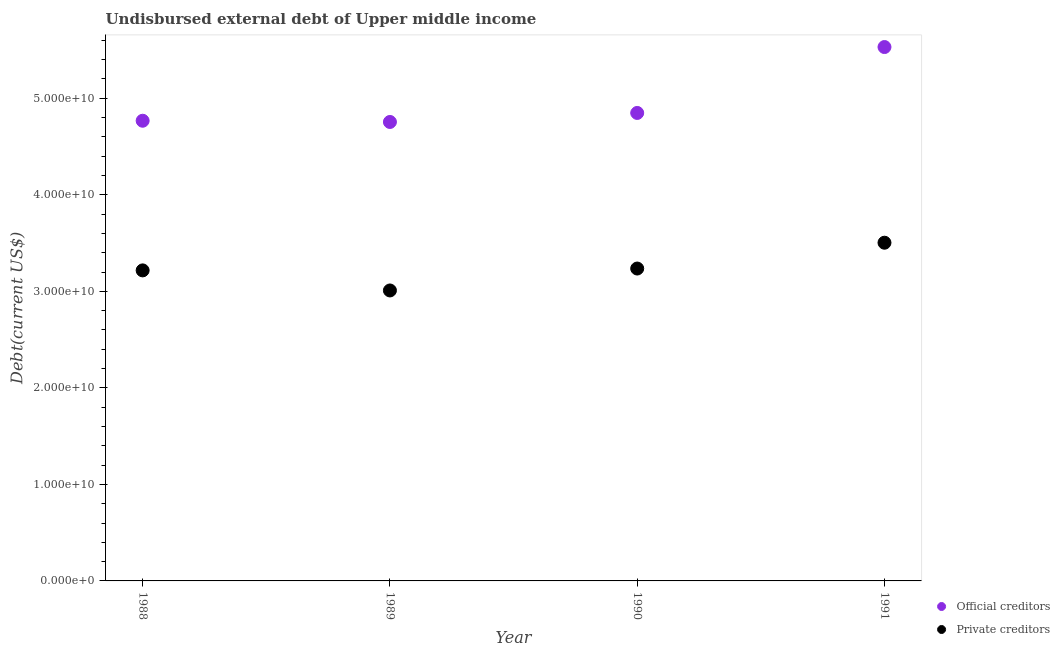How many different coloured dotlines are there?
Keep it short and to the point. 2. Is the number of dotlines equal to the number of legend labels?
Your answer should be very brief. Yes. What is the undisbursed external debt of private creditors in 1990?
Offer a terse response. 3.24e+1. Across all years, what is the maximum undisbursed external debt of official creditors?
Provide a short and direct response. 5.53e+1. Across all years, what is the minimum undisbursed external debt of private creditors?
Offer a terse response. 3.01e+1. In which year was the undisbursed external debt of official creditors maximum?
Give a very brief answer. 1991. In which year was the undisbursed external debt of official creditors minimum?
Provide a short and direct response. 1989. What is the total undisbursed external debt of official creditors in the graph?
Ensure brevity in your answer.  1.99e+11. What is the difference between the undisbursed external debt of official creditors in 1990 and that in 1991?
Offer a terse response. -6.83e+09. What is the difference between the undisbursed external debt of private creditors in 1990 and the undisbursed external debt of official creditors in 1991?
Keep it short and to the point. -2.29e+1. What is the average undisbursed external debt of official creditors per year?
Offer a terse response. 4.98e+1. In the year 1988, what is the difference between the undisbursed external debt of private creditors and undisbursed external debt of official creditors?
Provide a short and direct response. -1.55e+1. In how many years, is the undisbursed external debt of official creditors greater than 30000000000 US$?
Give a very brief answer. 4. What is the ratio of the undisbursed external debt of official creditors in 1988 to that in 1989?
Make the answer very short. 1. Is the undisbursed external debt of private creditors in 1988 less than that in 1991?
Your answer should be compact. Yes. What is the difference between the highest and the second highest undisbursed external debt of official creditors?
Give a very brief answer. 6.83e+09. What is the difference between the highest and the lowest undisbursed external debt of official creditors?
Your answer should be compact. 7.76e+09. Is the undisbursed external debt of private creditors strictly greater than the undisbursed external debt of official creditors over the years?
Provide a short and direct response. No. How many dotlines are there?
Your response must be concise. 2. What is the difference between two consecutive major ticks on the Y-axis?
Make the answer very short. 1.00e+1. Does the graph contain any zero values?
Make the answer very short. No. Where does the legend appear in the graph?
Your answer should be compact. Bottom right. What is the title of the graph?
Your answer should be compact. Undisbursed external debt of Upper middle income. What is the label or title of the Y-axis?
Provide a short and direct response. Debt(current US$). What is the Debt(current US$) of Official creditors in 1988?
Ensure brevity in your answer.  4.77e+1. What is the Debt(current US$) of Private creditors in 1988?
Offer a terse response. 3.22e+1. What is the Debt(current US$) in Official creditors in 1989?
Your response must be concise. 4.75e+1. What is the Debt(current US$) of Private creditors in 1989?
Provide a succinct answer. 3.01e+1. What is the Debt(current US$) in Official creditors in 1990?
Provide a short and direct response. 4.85e+1. What is the Debt(current US$) in Private creditors in 1990?
Offer a terse response. 3.24e+1. What is the Debt(current US$) in Official creditors in 1991?
Keep it short and to the point. 5.53e+1. What is the Debt(current US$) in Private creditors in 1991?
Offer a terse response. 3.50e+1. Across all years, what is the maximum Debt(current US$) in Official creditors?
Provide a succinct answer. 5.53e+1. Across all years, what is the maximum Debt(current US$) of Private creditors?
Your answer should be compact. 3.50e+1. Across all years, what is the minimum Debt(current US$) of Official creditors?
Make the answer very short. 4.75e+1. Across all years, what is the minimum Debt(current US$) in Private creditors?
Make the answer very short. 3.01e+1. What is the total Debt(current US$) in Official creditors in the graph?
Your answer should be very brief. 1.99e+11. What is the total Debt(current US$) of Private creditors in the graph?
Keep it short and to the point. 1.30e+11. What is the difference between the Debt(current US$) in Official creditors in 1988 and that in 1989?
Make the answer very short. 1.27e+08. What is the difference between the Debt(current US$) of Private creditors in 1988 and that in 1989?
Offer a very short reply. 2.08e+09. What is the difference between the Debt(current US$) of Official creditors in 1988 and that in 1990?
Your answer should be compact. -8.08e+08. What is the difference between the Debt(current US$) in Private creditors in 1988 and that in 1990?
Ensure brevity in your answer.  -1.92e+08. What is the difference between the Debt(current US$) of Official creditors in 1988 and that in 1991?
Offer a terse response. -7.63e+09. What is the difference between the Debt(current US$) of Private creditors in 1988 and that in 1991?
Keep it short and to the point. -2.87e+09. What is the difference between the Debt(current US$) in Official creditors in 1989 and that in 1990?
Ensure brevity in your answer.  -9.35e+08. What is the difference between the Debt(current US$) of Private creditors in 1989 and that in 1990?
Your response must be concise. -2.27e+09. What is the difference between the Debt(current US$) in Official creditors in 1989 and that in 1991?
Ensure brevity in your answer.  -7.76e+09. What is the difference between the Debt(current US$) of Private creditors in 1989 and that in 1991?
Your answer should be compact. -4.95e+09. What is the difference between the Debt(current US$) of Official creditors in 1990 and that in 1991?
Your response must be concise. -6.83e+09. What is the difference between the Debt(current US$) of Private creditors in 1990 and that in 1991?
Your answer should be very brief. -2.68e+09. What is the difference between the Debt(current US$) in Official creditors in 1988 and the Debt(current US$) in Private creditors in 1989?
Your answer should be very brief. 1.76e+1. What is the difference between the Debt(current US$) of Official creditors in 1988 and the Debt(current US$) of Private creditors in 1990?
Give a very brief answer. 1.53e+1. What is the difference between the Debt(current US$) of Official creditors in 1988 and the Debt(current US$) of Private creditors in 1991?
Give a very brief answer. 1.26e+1. What is the difference between the Debt(current US$) of Official creditors in 1989 and the Debt(current US$) of Private creditors in 1990?
Keep it short and to the point. 1.52e+1. What is the difference between the Debt(current US$) of Official creditors in 1989 and the Debt(current US$) of Private creditors in 1991?
Give a very brief answer. 1.25e+1. What is the difference between the Debt(current US$) in Official creditors in 1990 and the Debt(current US$) in Private creditors in 1991?
Make the answer very short. 1.34e+1. What is the average Debt(current US$) of Official creditors per year?
Your response must be concise. 4.98e+1. What is the average Debt(current US$) of Private creditors per year?
Keep it short and to the point. 3.24e+1. In the year 1988, what is the difference between the Debt(current US$) of Official creditors and Debt(current US$) of Private creditors?
Offer a terse response. 1.55e+1. In the year 1989, what is the difference between the Debt(current US$) in Official creditors and Debt(current US$) in Private creditors?
Make the answer very short. 1.75e+1. In the year 1990, what is the difference between the Debt(current US$) of Official creditors and Debt(current US$) of Private creditors?
Your answer should be very brief. 1.61e+1. In the year 1991, what is the difference between the Debt(current US$) of Official creditors and Debt(current US$) of Private creditors?
Your answer should be very brief. 2.03e+1. What is the ratio of the Debt(current US$) in Official creditors in 1988 to that in 1989?
Offer a terse response. 1. What is the ratio of the Debt(current US$) of Private creditors in 1988 to that in 1989?
Give a very brief answer. 1.07. What is the ratio of the Debt(current US$) in Official creditors in 1988 to that in 1990?
Keep it short and to the point. 0.98. What is the ratio of the Debt(current US$) of Private creditors in 1988 to that in 1990?
Give a very brief answer. 0.99. What is the ratio of the Debt(current US$) of Official creditors in 1988 to that in 1991?
Offer a very short reply. 0.86. What is the ratio of the Debt(current US$) of Private creditors in 1988 to that in 1991?
Offer a terse response. 0.92. What is the ratio of the Debt(current US$) of Official creditors in 1989 to that in 1990?
Keep it short and to the point. 0.98. What is the ratio of the Debt(current US$) in Private creditors in 1989 to that in 1990?
Ensure brevity in your answer.  0.93. What is the ratio of the Debt(current US$) of Official creditors in 1989 to that in 1991?
Your answer should be very brief. 0.86. What is the ratio of the Debt(current US$) of Private creditors in 1989 to that in 1991?
Give a very brief answer. 0.86. What is the ratio of the Debt(current US$) of Official creditors in 1990 to that in 1991?
Your answer should be compact. 0.88. What is the ratio of the Debt(current US$) of Private creditors in 1990 to that in 1991?
Your answer should be compact. 0.92. What is the difference between the highest and the second highest Debt(current US$) of Official creditors?
Provide a succinct answer. 6.83e+09. What is the difference between the highest and the second highest Debt(current US$) in Private creditors?
Give a very brief answer. 2.68e+09. What is the difference between the highest and the lowest Debt(current US$) in Official creditors?
Your answer should be compact. 7.76e+09. What is the difference between the highest and the lowest Debt(current US$) of Private creditors?
Your answer should be compact. 4.95e+09. 